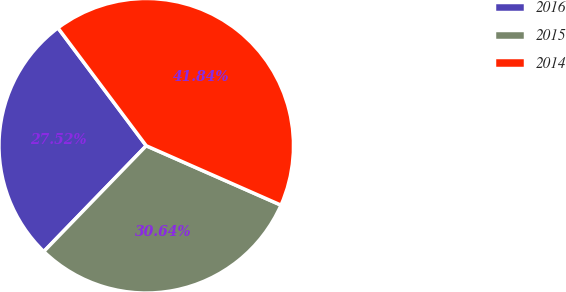Convert chart. <chart><loc_0><loc_0><loc_500><loc_500><pie_chart><fcel>2016<fcel>2015<fcel>2014<nl><fcel>27.52%<fcel>30.64%<fcel>41.84%<nl></chart> 